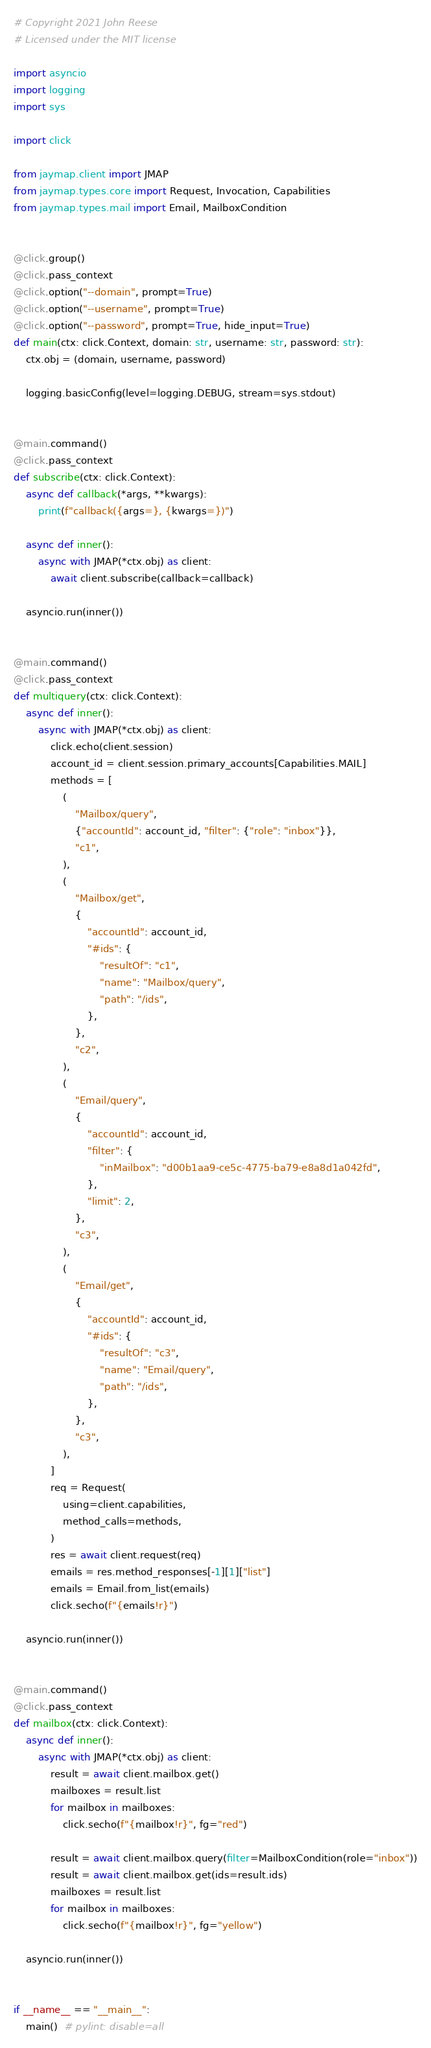<code> <loc_0><loc_0><loc_500><loc_500><_Python_># Copyright 2021 John Reese
# Licensed under the MIT license

import asyncio
import logging
import sys

import click

from jaymap.client import JMAP
from jaymap.types.core import Request, Invocation, Capabilities
from jaymap.types.mail import Email, MailboxCondition


@click.group()
@click.pass_context
@click.option("--domain", prompt=True)
@click.option("--username", prompt=True)
@click.option("--password", prompt=True, hide_input=True)
def main(ctx: click.Context, domain: str, username: str, password: str):
    ctx.obj = (domain, username, password)

    logging.basicConfig(level=logging.DEBUG, stream=sys.stdout)


@main.command()
@click.pass_context
def subscribe(ctx: click.Context):
    async def callback(*args, **kwargs):
        print(f"callback({args=}, {kwargs=})")

    async def inner():
        async with JMAP(*ctx.obj) as client:
            await client.subscribe(callback=callback)

    asyncio.run(inner())


@main.command()
@click.pass_context
def multiquery(ctx: click.Context):
    async def inner():
        async with JMAP(*ctx.obj) as client:
            click.echo(client.session)
            account_id = client.session.primary_accounts[Capabilities.MAIL]
            methods = [
                (
                    "Mailbox/query",
                    {"accountId": account_id, "filter": {"role": "inbox"}},
                    "c1",
                ),
                (
                    "Mailbox/get",
                    {
                        "accountId": account_id,
                        "#ids": {
                            "resultOf": "c1",
                            "name": "Mailbox/query",
                            "path": "/ids",
                        },
                    },
                    "c2",
                ),
                (
                    "Email/query",
                    {
                        "accountId": account_id,
                        "filter": {
                            "inMailbox": "d00b1aa9-ce5c-4775-ba79-e8a8d1a042fd",
                        },
                        "limit": 2,
                    },
                    "c3",
                ),
                (
                    "Email/get",
                    {
                        "accountId": account_id,
                        "#ids": {
                            "resultOf": "c3",
                            "name": "Email/query",
                            "path": "/ids",
                        },
                    },
                    "c3",
                ),
            ]
            req = Request(
                using=client.capabilities,
                method_calls=methods,
            )
            res = await client.request(req)
            emails = res.method_responses[-1][1]["list"]
            emails = Email.from_list(emails)
            click.secho(f"{emails!r}")

    asyncio.run(inner())


@main.command()
@click.pass_context
def mailbox(ctx: click.Context):
    async def inner():
        async with JMAP(*ctx.obj) as client:
            result = await client.mailbox.get()
            mailboxes = result.list
            for mailbox in mailboxes:
                click.secho(f"{mailbox!r}", fg="red")

            result = await client.mailbox.query(filter=MailboxCondition(role="inbox"))
            result = await client.mailbox.get(ids=result.ids)
            mailboxes = result.list
            for mailbox in mailboxes:
                click.secho(f"{mailbox!r}", fg="yellow")

    asyncio.run(inner())


if __name__ == "__main__":
    main()  # pylint: disable=all
</code> 